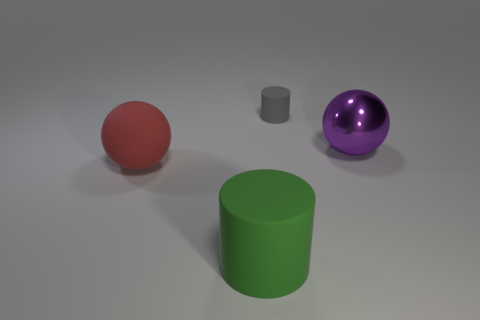There is a large object that is behind the ball that is left of the rubber thing behind the purple shiny sphere; what is its material?
Provide a succinct answer. Metal. There is a tiny thing that is made of the same material as the big red ball; what shape is it?
Ensure brevity in your answer.  Cylinder. Is there any other thing that has the same color as the big matte cylinder?
Provide a short and direct response. No. How many metal things are in front of the matte thing behind the large sphere that is behind the rubber ball?
Offer a terse response. 1. How many purple things are big matte things or objects?
Provide a short and direct response. 1. Do the gray matte object and the ball left of the large purple shiny thing have the same size?
Ensure brevity in your answer.  No. There is a big green object that is the same shape as the tiny gray object; what is its material?
Your answer should be very brief. Rubber. How many other objects are the same size as the metallic ball?
Your answer should be compact. 2. The thing that is in front of the big thing to the left of the matte cylinder left of the gray matte object is what shape?
Your answer should be compact. Cylinder. What is the shape of the matte thing that is in front of the gray object and to the right of the red rubber object?
Ensure brevity in your answer.  Cylinder. 